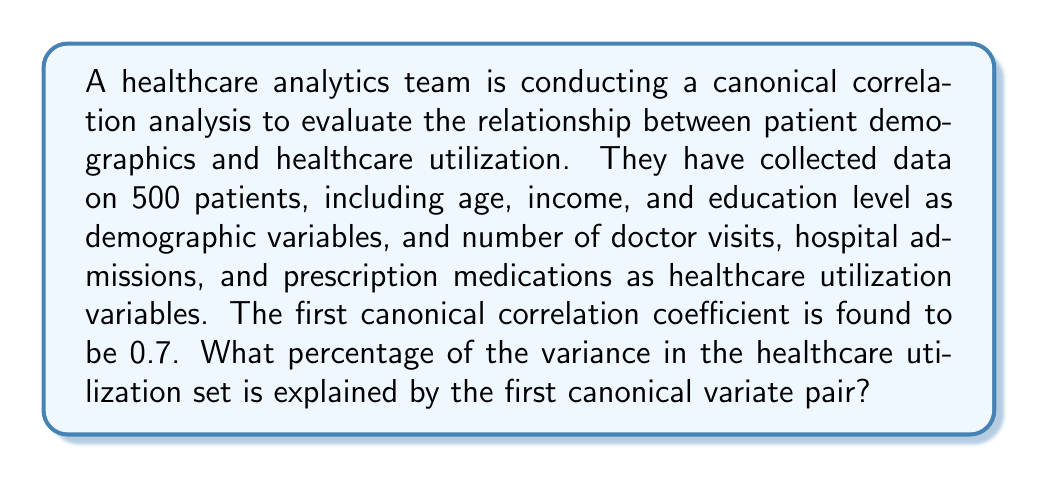Teach me how to tackle this problem. To solve this problem, we need to understand the concept of canonical correlation analysis and how to interpret its results. Here's a step-by-step explanation:

1. Canonical correlation analysis (CCA) examines the relationship between two sets of variables, in this case, patient demographics and healthcare utilization.

2. The canonical correlation coefficient (r) represents the strength of the relationship between the canonical variates derived from each set of variables.

3. The square of the canonical correlation coefficient (r²) represents the amount of shared variance between the two canonical variates.

4. To calculate the percentage of variance explained in the healthcare utilization set by the first canonical variate pair, we need to square the given canonical correlation coefficient:

   $$r^2 = (0.7)^2 = 0.49$$

5. This means that 49% of the variance in the healthcare utilization canonical variate is shared with the demographic canonical variate.

6. To express this as a percentage, we multiply by 100:

   $$0.49 \times 100 = 49\%$$

Therefore, 49% of the variance in the healthcare utilization set is explained by the first canonical variate pair.
Answer: 49% 